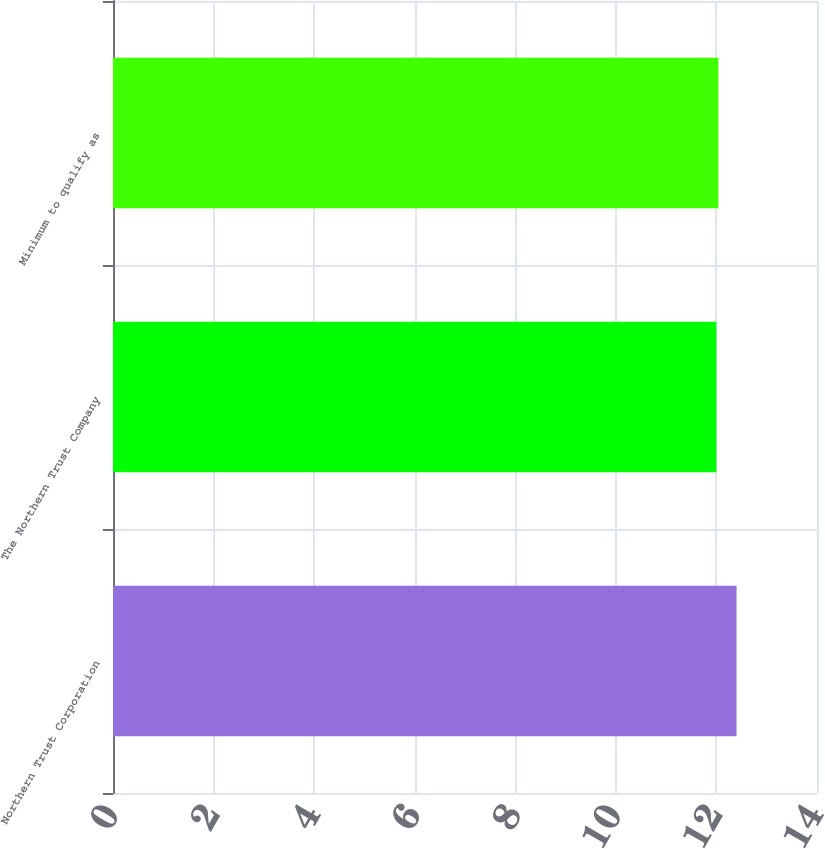<chart> <loc_0><loc_0><loc_500><loc_500><bar_chart><fcel>Northern Trust Corporation<fcel>The Northern Trust Company<fcel>Minimum to qualify as<nl><fcel>12.4<fcel>12<fcel>12.04<nl></chart> 